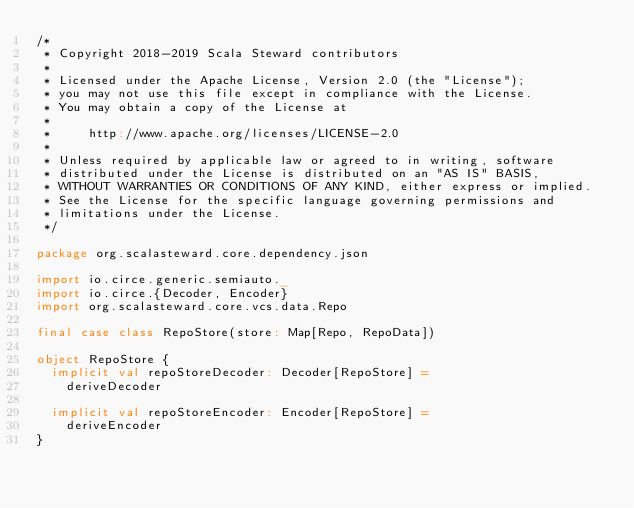<code> <loc_0><loc_0><loc_500><loc_500><_Scala_>/*
 * Copyright 2018-2019 Scala Steward contributors
 *
 * Licensed under the Apache License, Version 2.0 (the "License");
 * you may not use this file except in compliance with the License.
 * You may obtain a copy of the License at
 *
 *     http://www.apache.org/licenses/LICENSE-2.0
 *
 * Unless required by applicable law or agreed to in writing, software
 * distributed under the License is distributed on an "AS IS" BASIS,
 * WITHOUT WARRANTIES OR CONDITIONS OF ANY KIND, either express or implied.
 * See the License for the specific language governing permissions and
 * limitations under the License.
 */

package org.scalasteward.core.dependency.json

import io.circe.generic.semiauto._
import io.circe.{Decoder, Encoder}
import org.scalasteward.core.vcs.data.Repo

final case class RepoStore(store: Map[Repo, RepoData])

object RepoStore {
  implicit val repoStoreDecoder: Decoder[RepoStore] =
    deriveDecoder

  implicit val repoStoreEncoder: Encoder[RepoStore] =
    deriveEncoder
}
</code> 